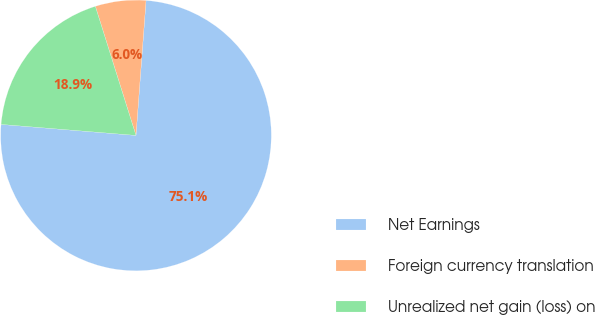<chart> <loc_0><loc_0><loc_500><loc_500><pie_chart><fcel>Net Earnings<fcel>Foreign currency translation<fcel>Unrealized net gain (loss) on<nl><fcel>75.11%<fcel>6.04%<fcel>18.85%<nl></chart> 